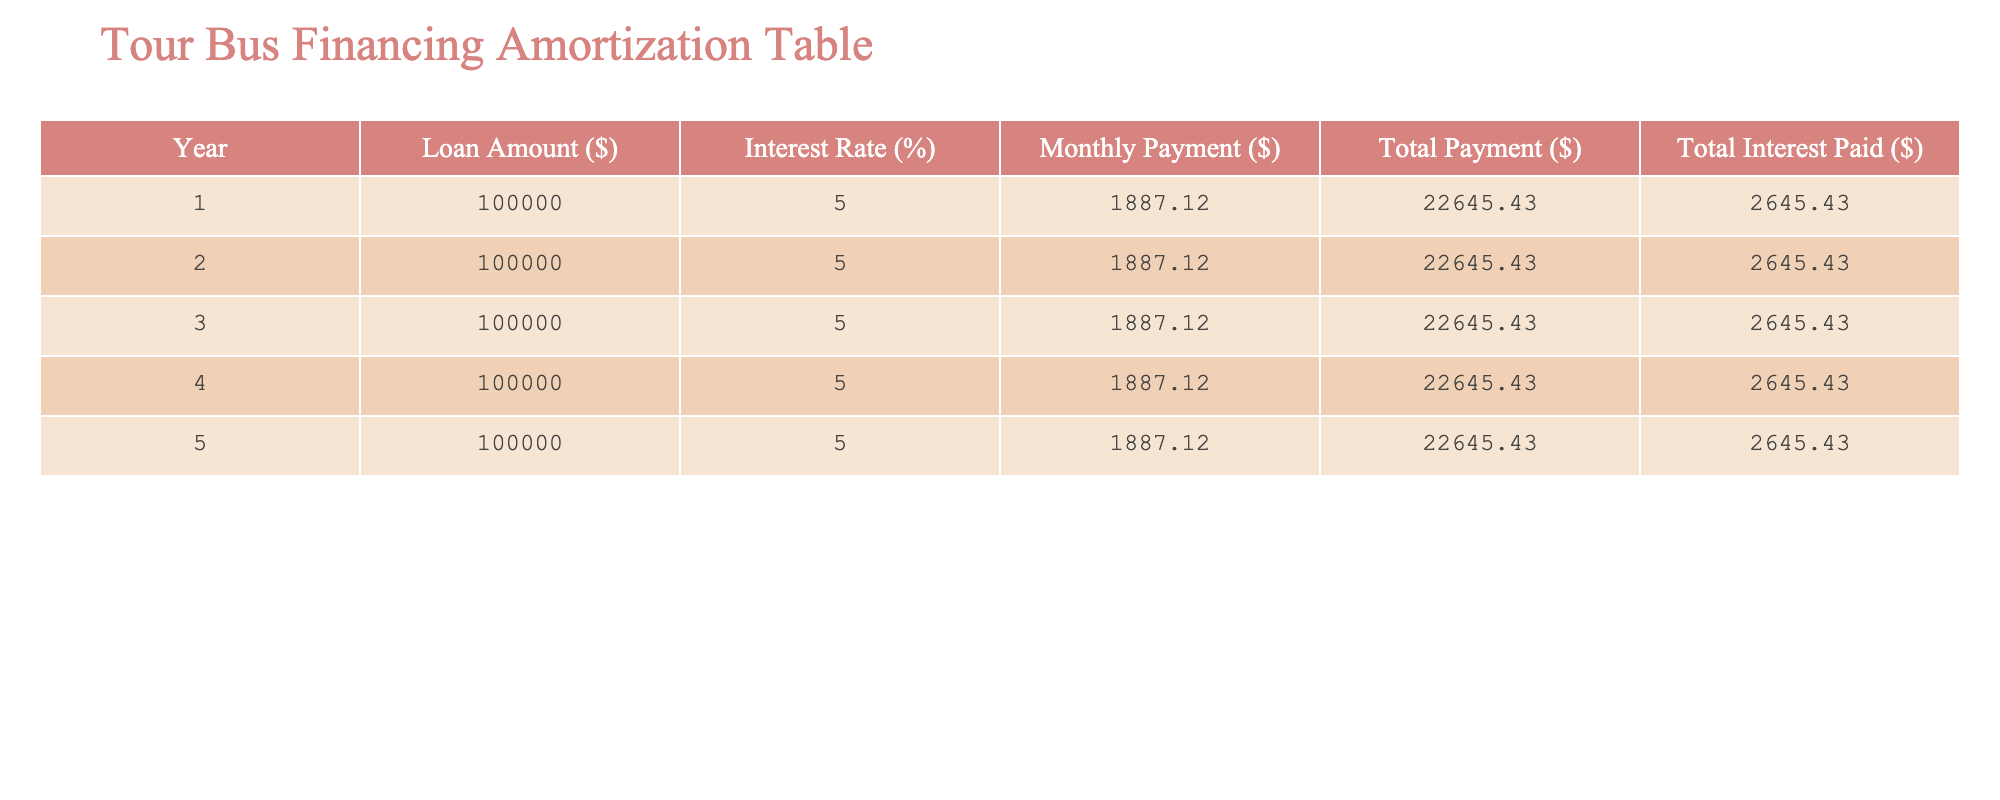What is the total loan amount for the 5 years? Each year has a loan amount of 100,000 dollars, and there are 5 years. Therefore, the total loan amount is 100,000 * 5 = 500,000 dollars.
Answer: 500,000 What is the monthly payment amount for each year? The monthly payment is listed as 1,887.12 dollars for each year in the table.
Answer: 1,887.12 How much total interest is paid over the 5 years? The total interest paid for each year is 2,645.43 dollars, and for 5 years, the total interest paid is 2,645.43 * 5 = 13,227.15 dollars.
Answer: 13,227.15 Is the interest rate constant over the years? Yes, the interest rate remains at 5.0% for all 5 years as indicated in the table.
Answer: Yes What is the total payment after 3 years? For 3 years, the total payment would be 22,645.43 * 3 = 67,936.29 dollars. Adding the smaller amounts from the individual years confirms the total for 3 years.
Answer: 67,936.29 How much does the total payment increase from year 1 to year 5? The total payment remains the same at 22,645.43 dollars for all years. Therefore, the increase from year 1 to year 5 is 0 dollars.
Answer: 0 What is the average monthly payment over the 5 years? The monthly payment is consistent at 1,887.12 dollars for each year. Since it is the same for 5 years, the average is also 1,887.12 dollars.
Answer: 1,887.12 If the total interest paid was used to help fund a band tour, how much total would be available after 5 years? The total interest paid over 5 years is 13,227.15 dollars, which could be used for the band tour after 5 years as it is the cumulative amount.
Answer: 13,227.15 How much would be saved in interest if the loan term were reduced to 3 years using the same loan amount and rate? This question involves more complexity as it requires calculating the total payments for a shorter term and comparing it with the current total interest. The total interest for 3 years would be less than 13,227.15 as per amortization principles because of reduced payments.
Answer: Requires calculation 